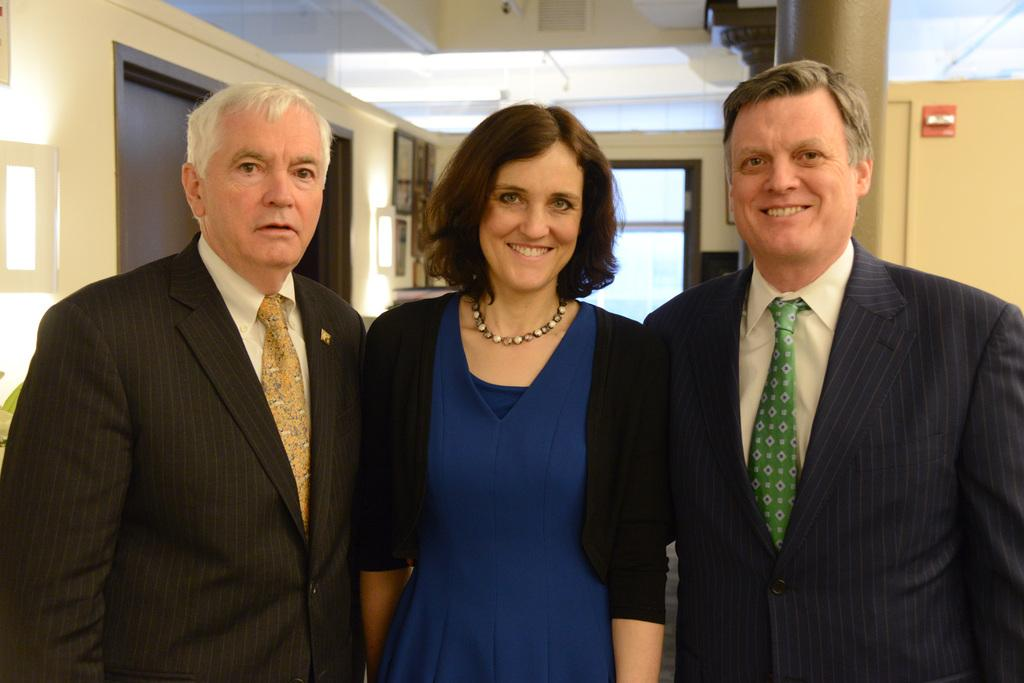How many people are in the image? There are persons in the image, but the exact number is not specified. What can be seen in the background of the image? There is a wall in the background of the image. What type of sand can be seen in the image? There is no sand present in the image. What hobbies do the persons in the image enjoy? The provided facts do not give any information about the hobbies of the persons in the image. What wish do the persons in the image have? The provided facts do not give any information about the wishes of the persons in the image. 